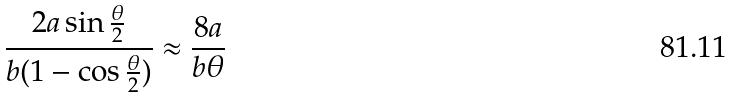Convert formula to latex. <formula><loc_0><loc_0><loc_500><loc_500>\frac { 2 a \sin \frac { \theta } { 2 } } { b ( 1 - \cos \frac { \theta } { 2 } ) } \approx \frac { 8 a } { b \theta }</formula> 